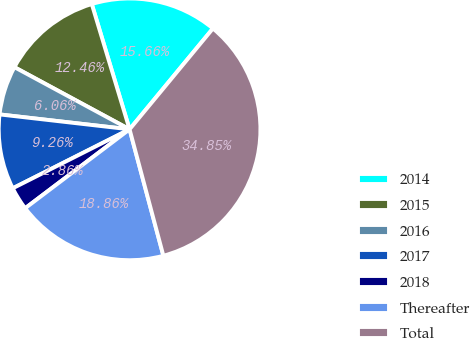<chart> <loc_0><loc_0><loc_500><loc_500><pie_chart><fcel>2014<fcel>2015<fcel>2016<fcel>2017<fcel>2018<fcel>Thereafter<fcel>Total<nl><fcel>15.66%<fcel>12.46%<fcel>6.06%<fcel>9.26%<fcel>2.86%<fcel>18.86%<fcel>34.85%<nl></chart> 